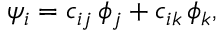<formula> <loc_0><loc_0><loc_500><loc_500>\psi _ { i } = c _ { i j } \, \phi _ { j } + c _ { i k } \, \phi _ { k } ,</formula> 